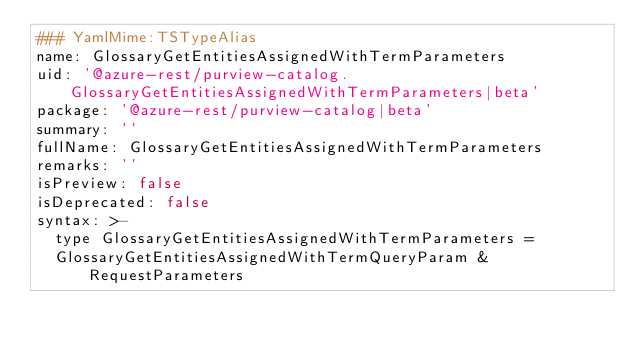Convert code to text. <code><loc_0><loc_0><loc_500><loc_500><_YAML_>### YamlMime:TSTypeAlias
name: GlossaryGetEntitiesAssignedWithTermParameters
uid: '@azure-rest/purview-catalog.GlossaryGetEntitiesAssignedWithTermParameters|beta'
package: '@azure-rest/purview-catalog|beta'
summary: ''
fullName: GlossaryGetEntitiesAssignedWithTermParameters
remarks: ''
isPreview: false
isDeprecated: false
syntax: >-
  type GlossaryGetEntitiesAssignedWithTermParameters =
  GlossaryGetEntitiesAssignedWithTermQueryParam & RequestParameters
</code> 